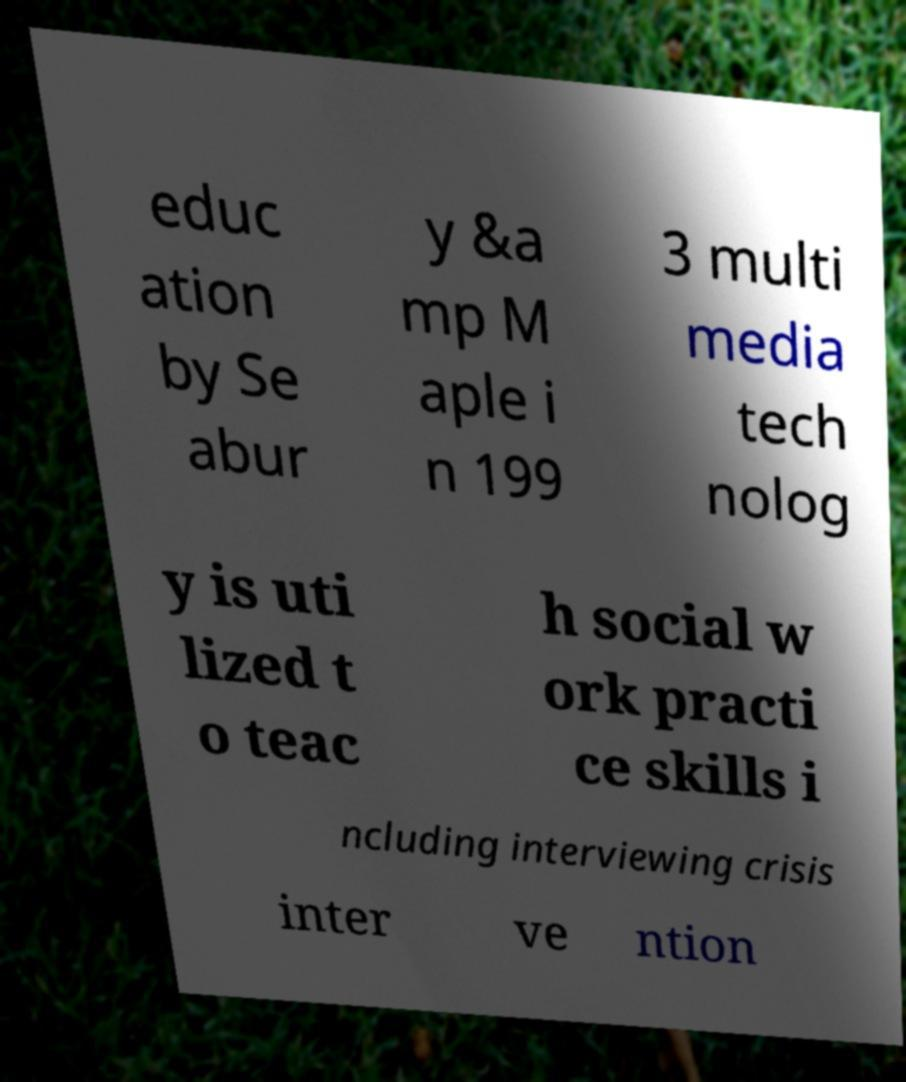Please read and relay the text visible in this image. What does it say? educ ation by Se abur y &a mp M aple i n 199 3 multi media tech nolog y is uti lized t o teac h social w ork practi ce skills i ncluding interviewing crisis inter ve ntion 